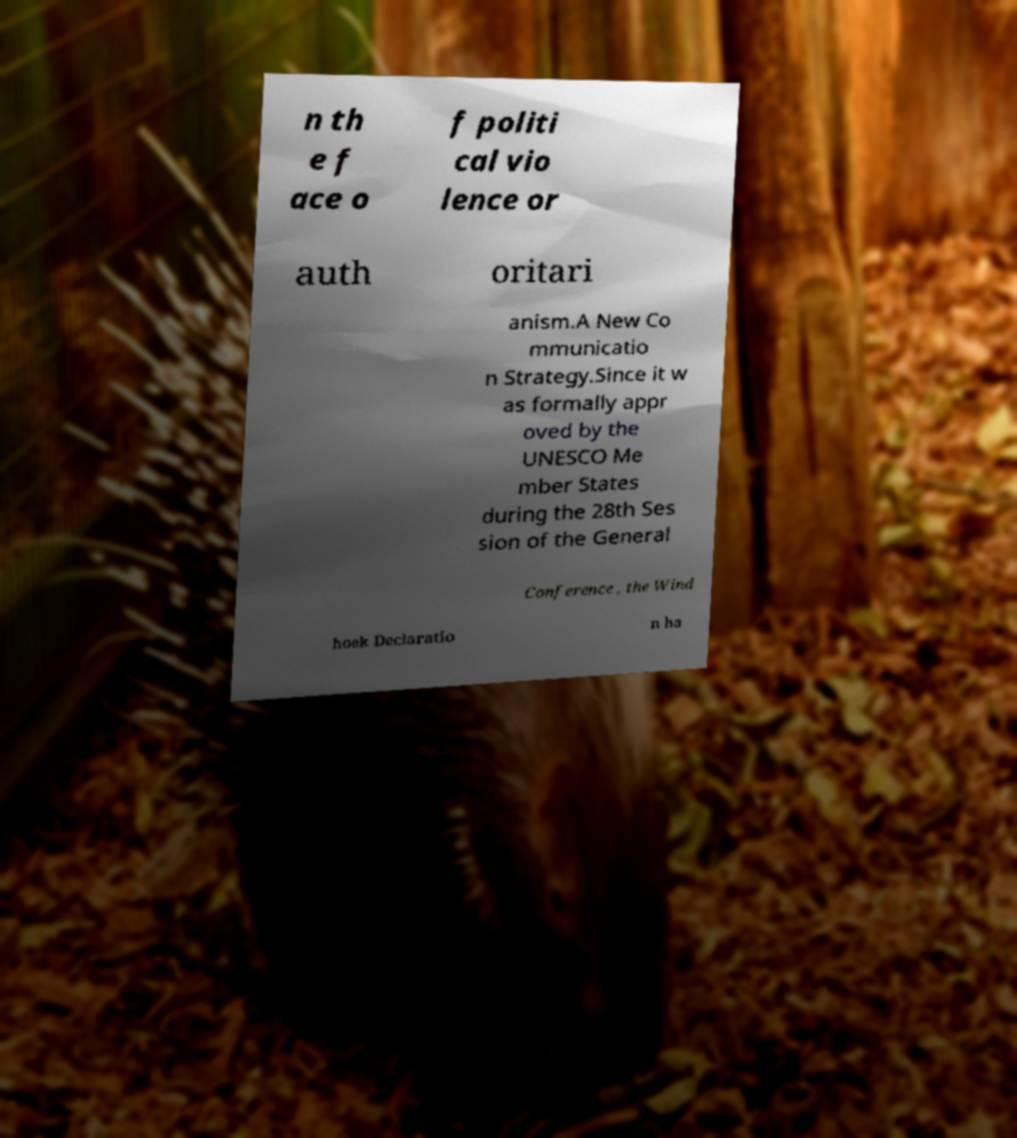Please identify and transcribe the text found in this image. n th e f ace o f politi cal vio lence or auth oritari anism.A New Co mmunicatio n Strategy.Since it w as formally appr oved by the UNESCO Me mber States during the 28th Ses sion of the General Conference , the Wind hoek Declaratio n ha 